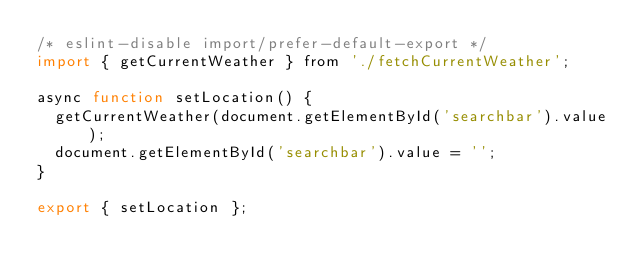Convert code to text. <code><loc_0><loc_0><loc_500><loc_500><_JavaScript_>/* eslint-disable import/prefer-default-export */
import { getCurrentWeather } from './fetchCurrentWeather';

async function setLocation() {
  getCurrentWeather(document.getElementById('searchbar').value);
  document.getElementById('searchbar').value = '';
}

export { setLocation };
</code> 